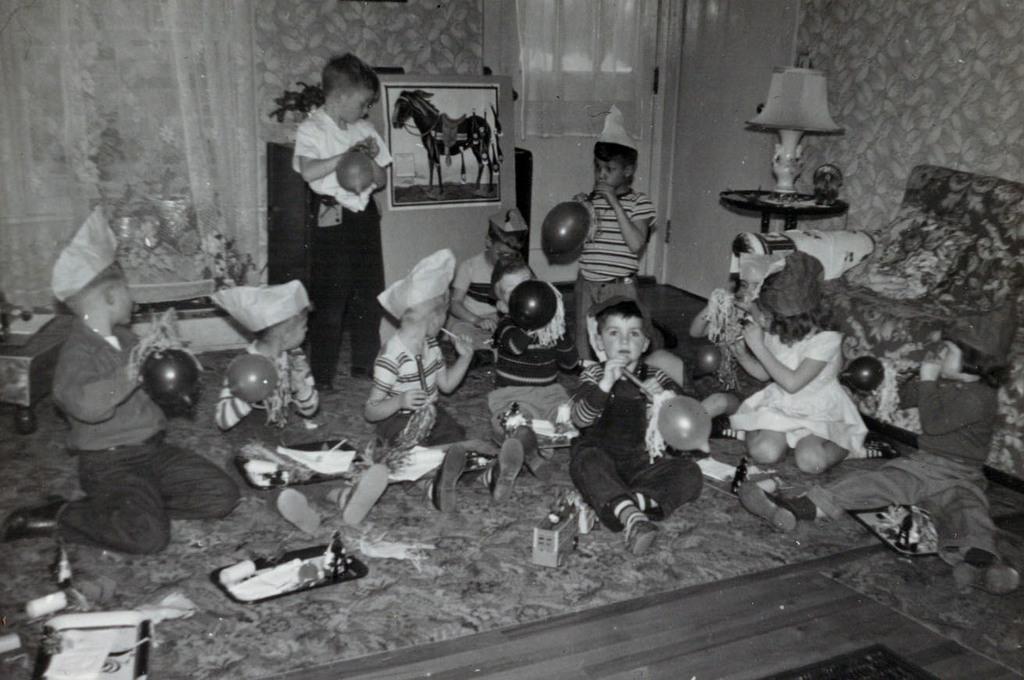Please provide a concise description of this image. This is a black and white image. In this picture we can see some kids are sitting and some of them are holding balloons and wearing cap. In the background of the image we can see curtain, wall, cupboard, plant, photo frame, lamp, couch, door, wall. At the bottom of the image we can see the floor. In the background of the image we can see some toys. 